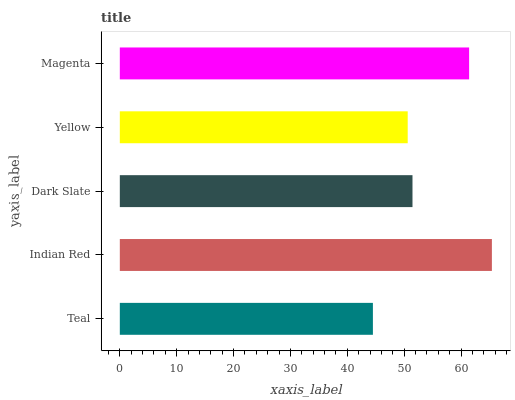Is Teal the minimum?
Answer yes or no. Yes. Is Indian Red the maximum?
Answer yes or no. Yes. Is Dark Slate the minimum?
Answer yes or no. No. Is Dark Slate the maximum?
Answer yes or no. No. Is Indian Red greater than Dark Slate?
Answer yes or no. Yes. Is Dark Slate less than Indian Red?
Answer yes or no. Yes. Is Dark Slate greater than Indian Red?
Answer yes or no. No. Is Indian Red less than Dark Slate?
Answer yes or no. No. Is Dark Slate the high median?
Answer yes or no. Yes. Is Dark Slate the low median?
Answer yes or no. Yes. Is Yellow the high median?
Answer yes or no. No. Is Magenta the low median?
Answer yes or no. No. 